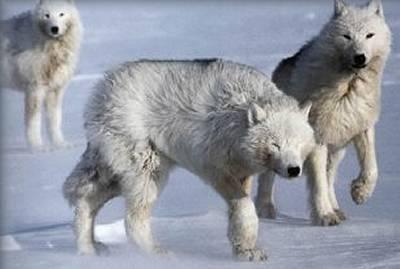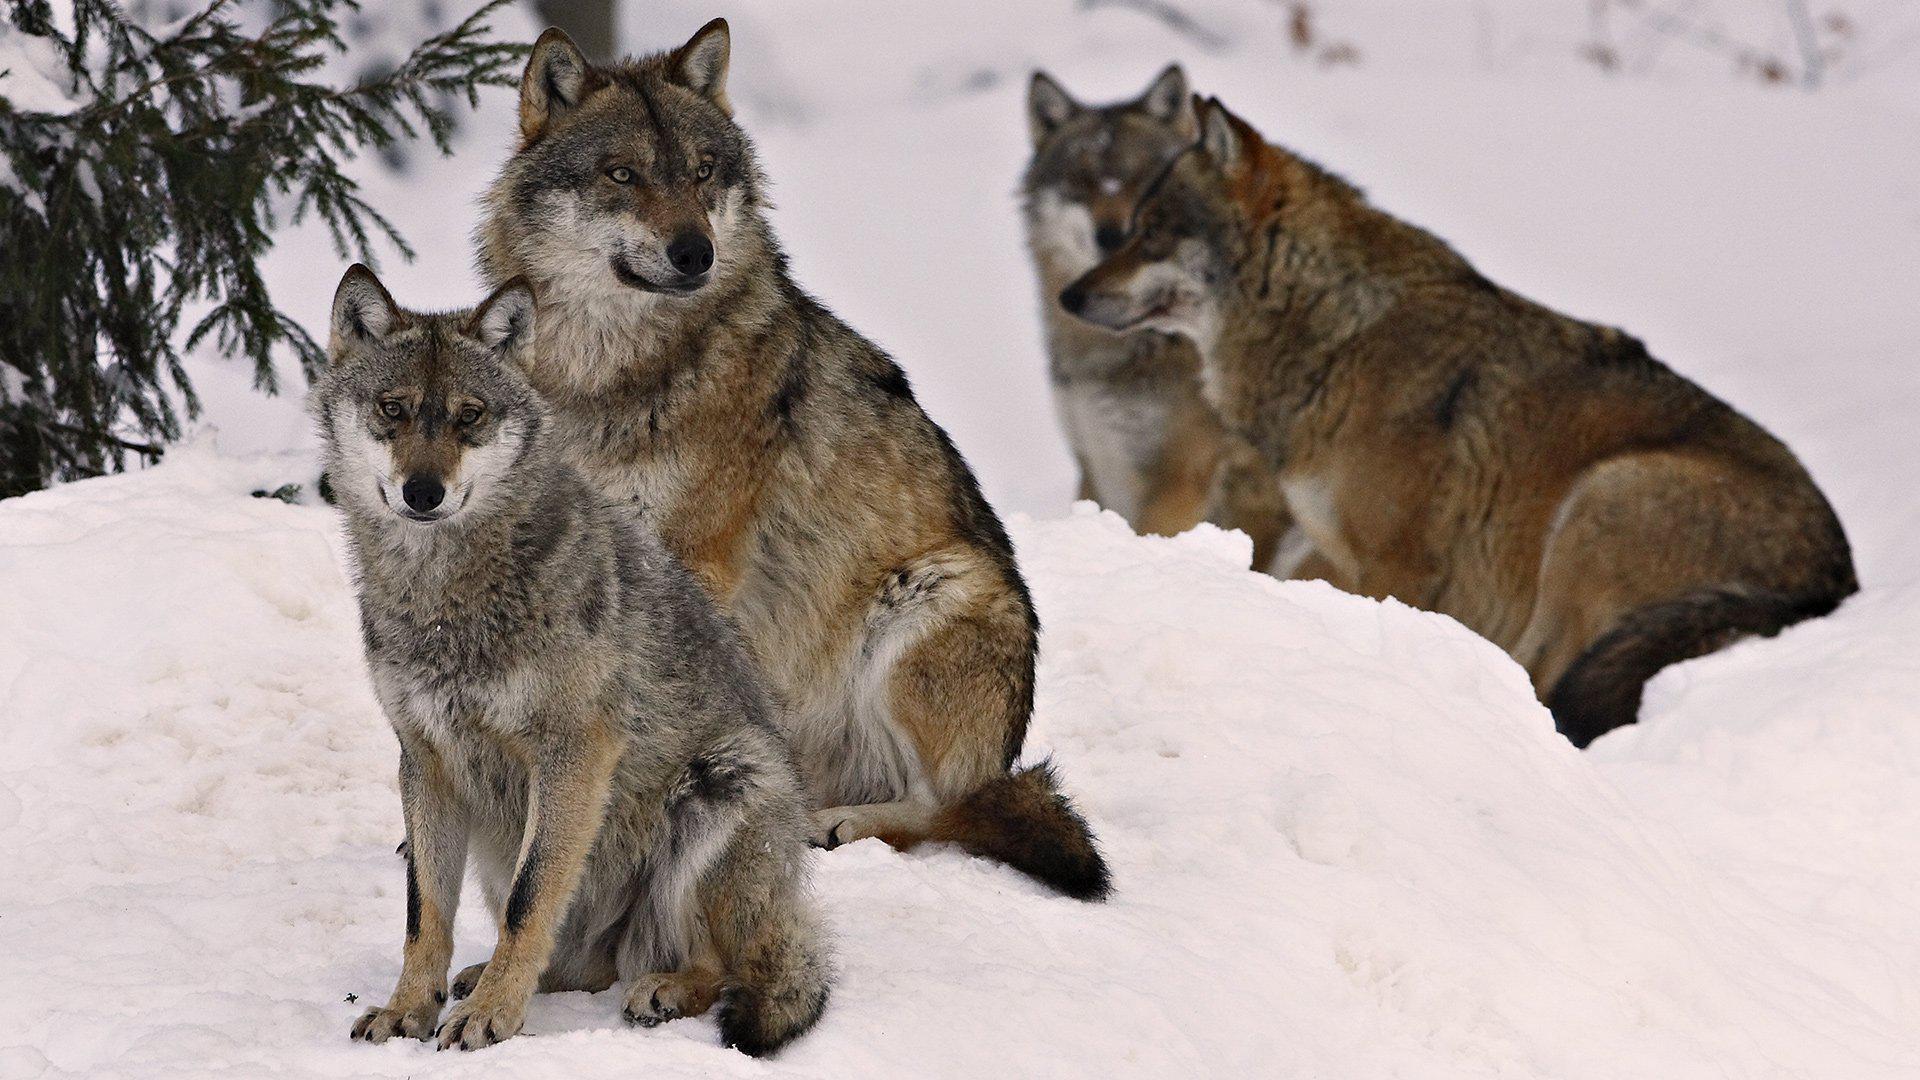The first image is the image on the left, the second image is the image on the right. For the images shown, is this caption "Each image shows at least three wolves in a snowy scene, and no carcass is visible in either scene." true? Answer yes or no. Yes. The first image is the image on the left, the second image is the image on the right. For the images shown, is this caption "There are more than six wolves." true? Answer yes or no. No. 